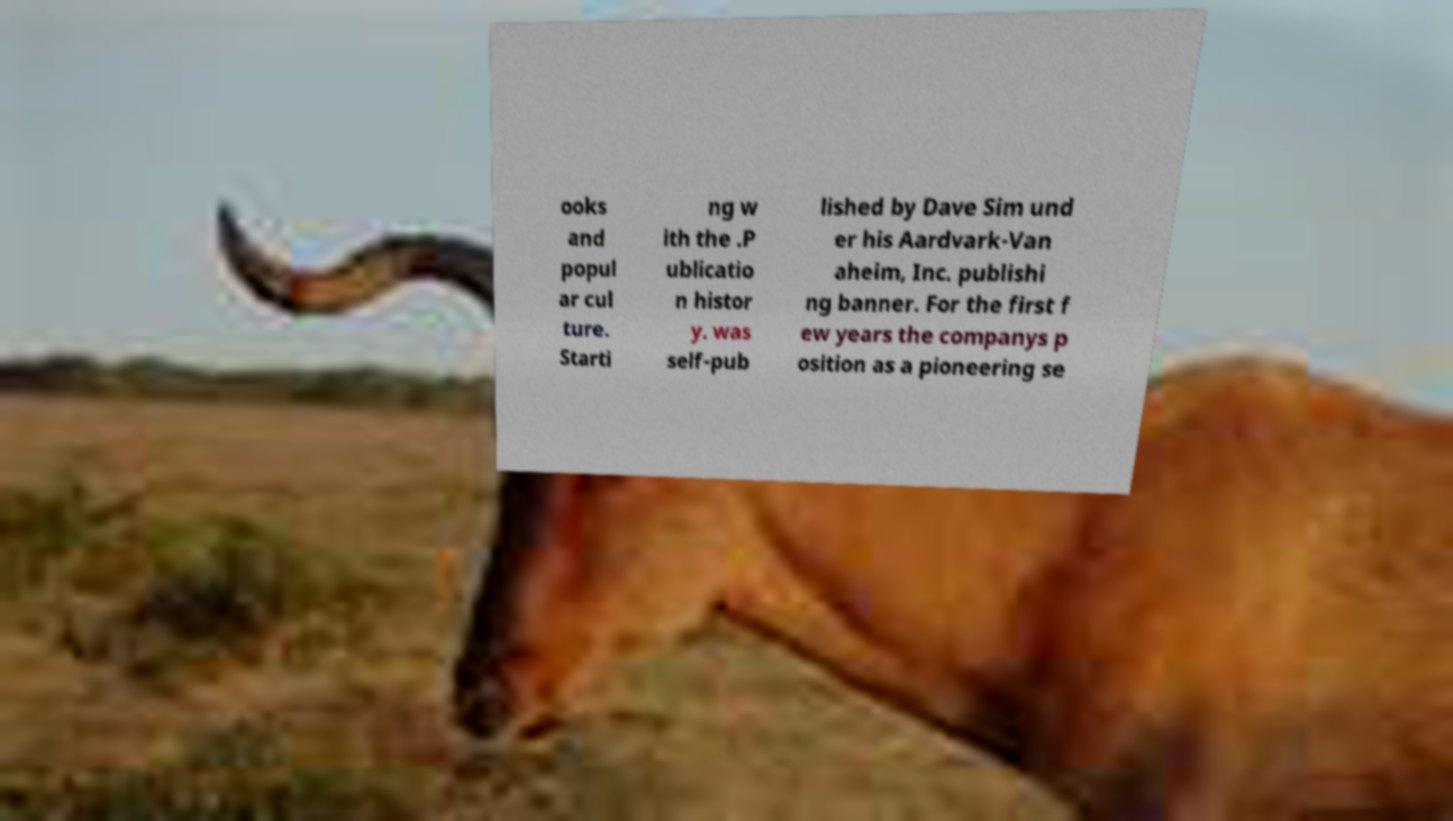Please identify and transcribe the text found in this image. ooks and popul ar cul ture. Starti ng w ith the .P ublicatio n histor y. was self-pub lished by Dave Sim und er his Aardvark-Van aheim, Inc. publishi ng banner. For the first f ew years the companys p osition as a pioneering se 